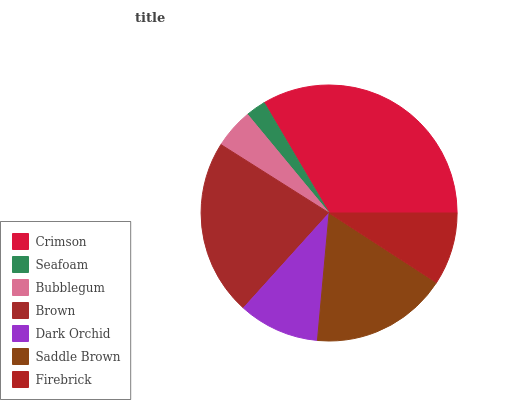Is Seafoam the minimum?
Answer yes or no. Yes. Is Crimson the maximum?
Answer yes or no. Yes. Is Bubblegum the minimum?
Answer yes or no. No. Is Bubblegum the maximum?
Answer yes or no. No. Is Bubblegum greater than Seafoam?
Answer yes or no. Yes. Is Seafoam less than Bubblegum?
Answer yes or no. Yes. Is Seafoam greater than Bubblegum?
Answer yes or no. No. Is Bubblegum less than Seafoam?
Answer yes or no. No. Is Dark Orchid the high median?
Answer yes or no. Yes. Is Dark Orchid the low median?
Answer yes or no. Yes. Is Brown the high median?
Answer yes or no. No. Is Saddle Brown the low median?
Answer yes or no. No. 